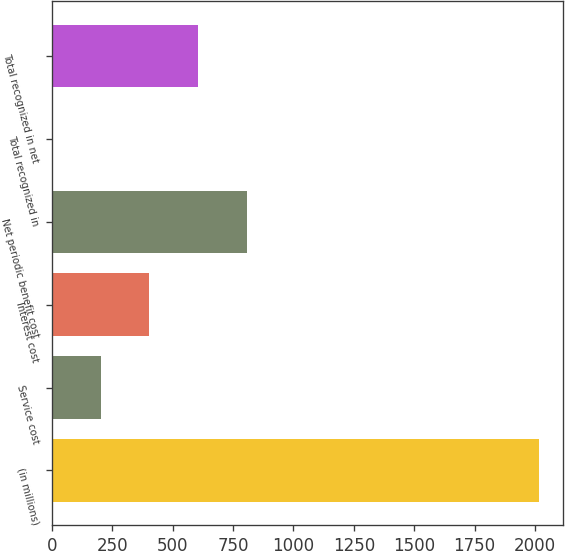Convert chart. <chart><loc_0><loc_0><loc_500><loc_500><bar_chart><fcel>(in millions)<fcel>Service cost<fcel>Interest cost<fcel>Net periodic benefit cost<fcel>Total recognized in<fcel>Total recognized in net<nl><fcel>2016<fcel>202.5<fcel>404<fcel>807<fcel>1<fcel>605.5<nl></chart> 